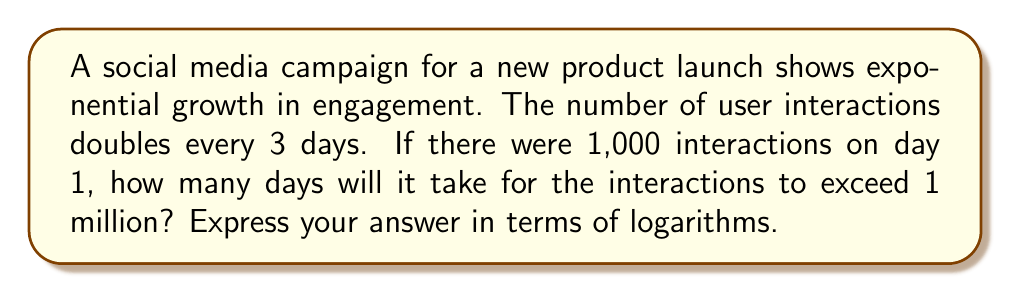Help me with this question. Let's approach this step-by-step:

1) Let $N$ be the number of 3-day periods needed to exceed 1 million interactions.

2) We can express this as an exponential equation:
   $1000 \cdot 2^N > 1,000,000$

3) Simplify the right side:
   $1000 \cdot 2^N > 10^6$

4) Divide both sides by 1000:
   $2^N > 10^3$

5) Take the logarithm (base 2) of both sides:
   $\log_2(2^N) > \log_2(10^3)$

6) Simplify the left side using the logarithm property $\log_a(a^x) = x$:
   $N > \log_2(10^3)$

7) We need the smallest integer $N$ that satisfies this inequality. In mathematical notation, this is represented by the ceiling function:
   $N = \lceil \log_2(10^3) \rceil$

8) To get the number of days, we multiply $N$ by 3:
   Days $= 3 \cdot \lceil \log_2(10^3) \rceil$
Answer: $3 \cdot \lceil \log_2(10^3) \rceil$ days 